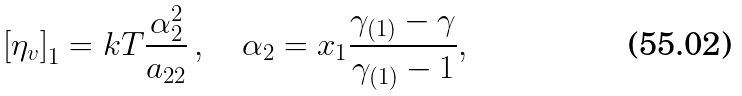<formula> <loc_0><loc_0><loc_500><loc_500>\left [ \eta _ { v } \right ] _ { 1 } = k T \frac { \alpha _ { 2 } ^ { 2 } } { a _ { 2 2 } } \, , \quad \alpha _ { 2 } = x _ { 1 } \frac { \gamma _ { ( 1 ) } - \gamma } { \gamma _ { ( 1 ) } - 1 } ,</formula> 